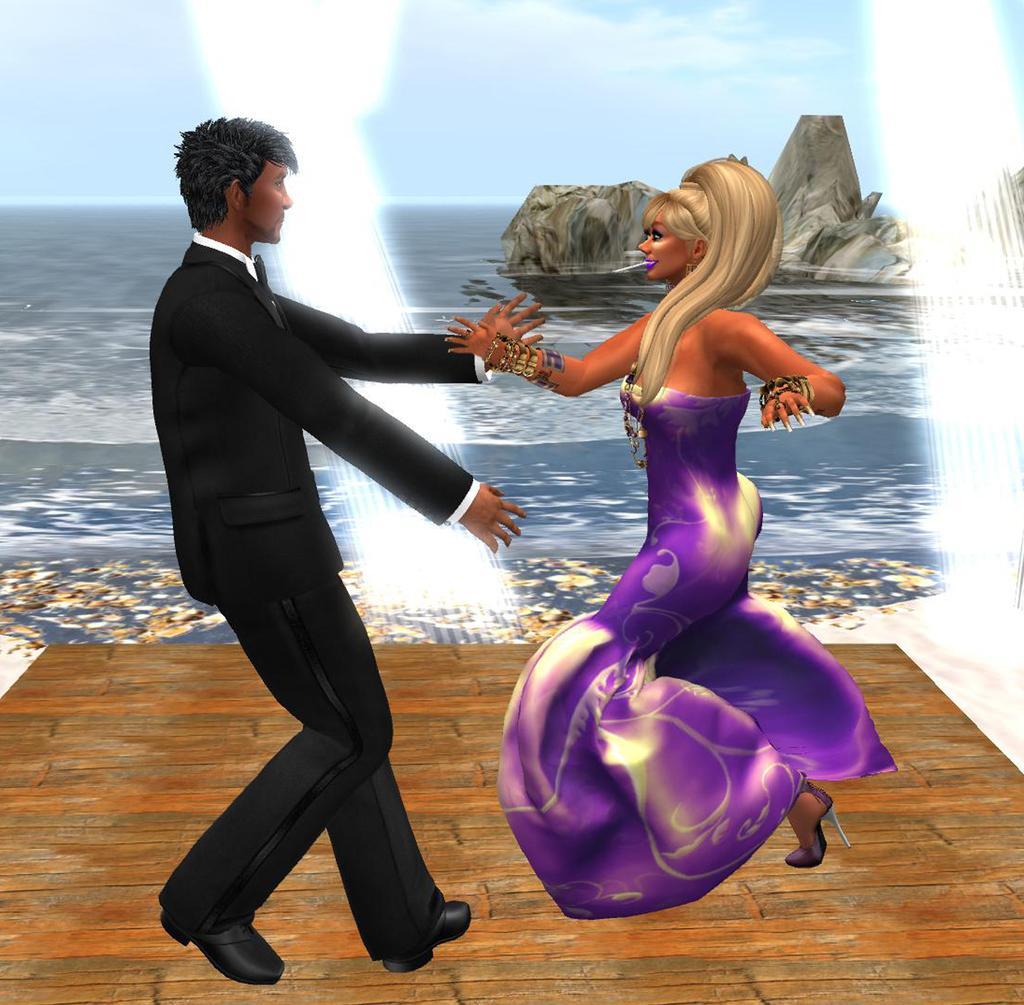Can you describe this image briefly? In this image I can see depiction picture where I can see a man, a woman, water and the sky. 